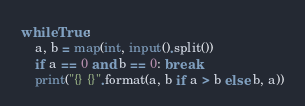Convert code to text. <code><loc_0><loc_0><loc_500><loc_500><_Python_>while True:
    a, b = map(int, input().split())
    if a == 0 and b == 0: break
    print("{} {}".format(a, b if a > b else b, a))</code> 